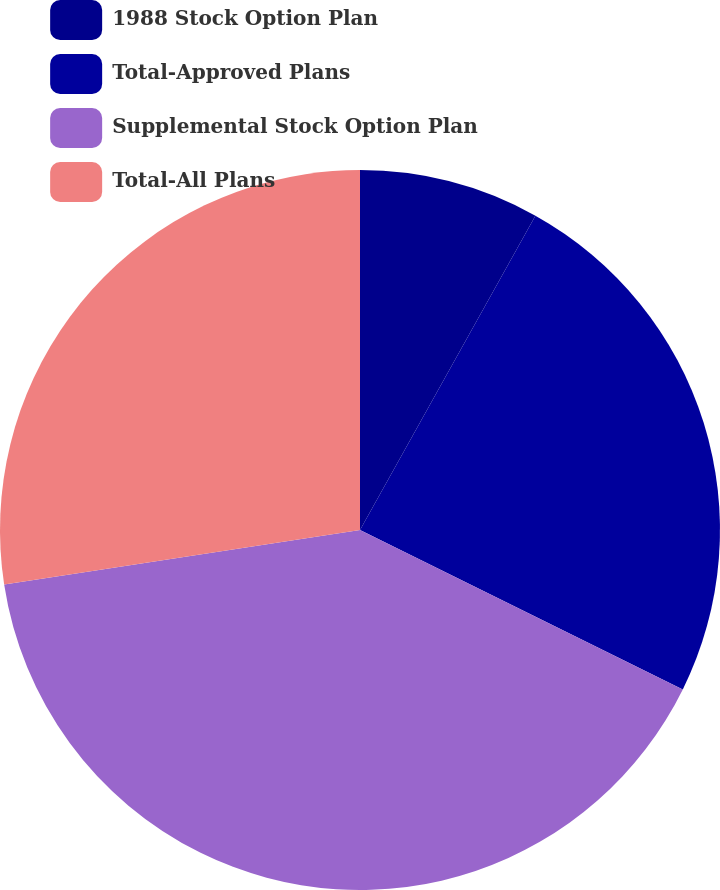Convert chart. <chart><loc_0><loc_0><loc_500><loc_500><pie_chart><fcel>1988 Stock Option Plan<fcel>Total-Approved Plans<fcel>Supplemental Stock Option Plan<fcel>Total-All Plans<nl><fcel>8.1%<fcel>24.2%<fcel>40.28%<fcel>27.42%<nl></chart> 